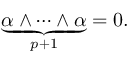<formula> <loc_0><loc_0><loc_500><loc_500>\ { \underset { p + 1 } { \underbrace { \alpha \wedge \cdots \wedge \alpha } } } = 0 .</formula> 